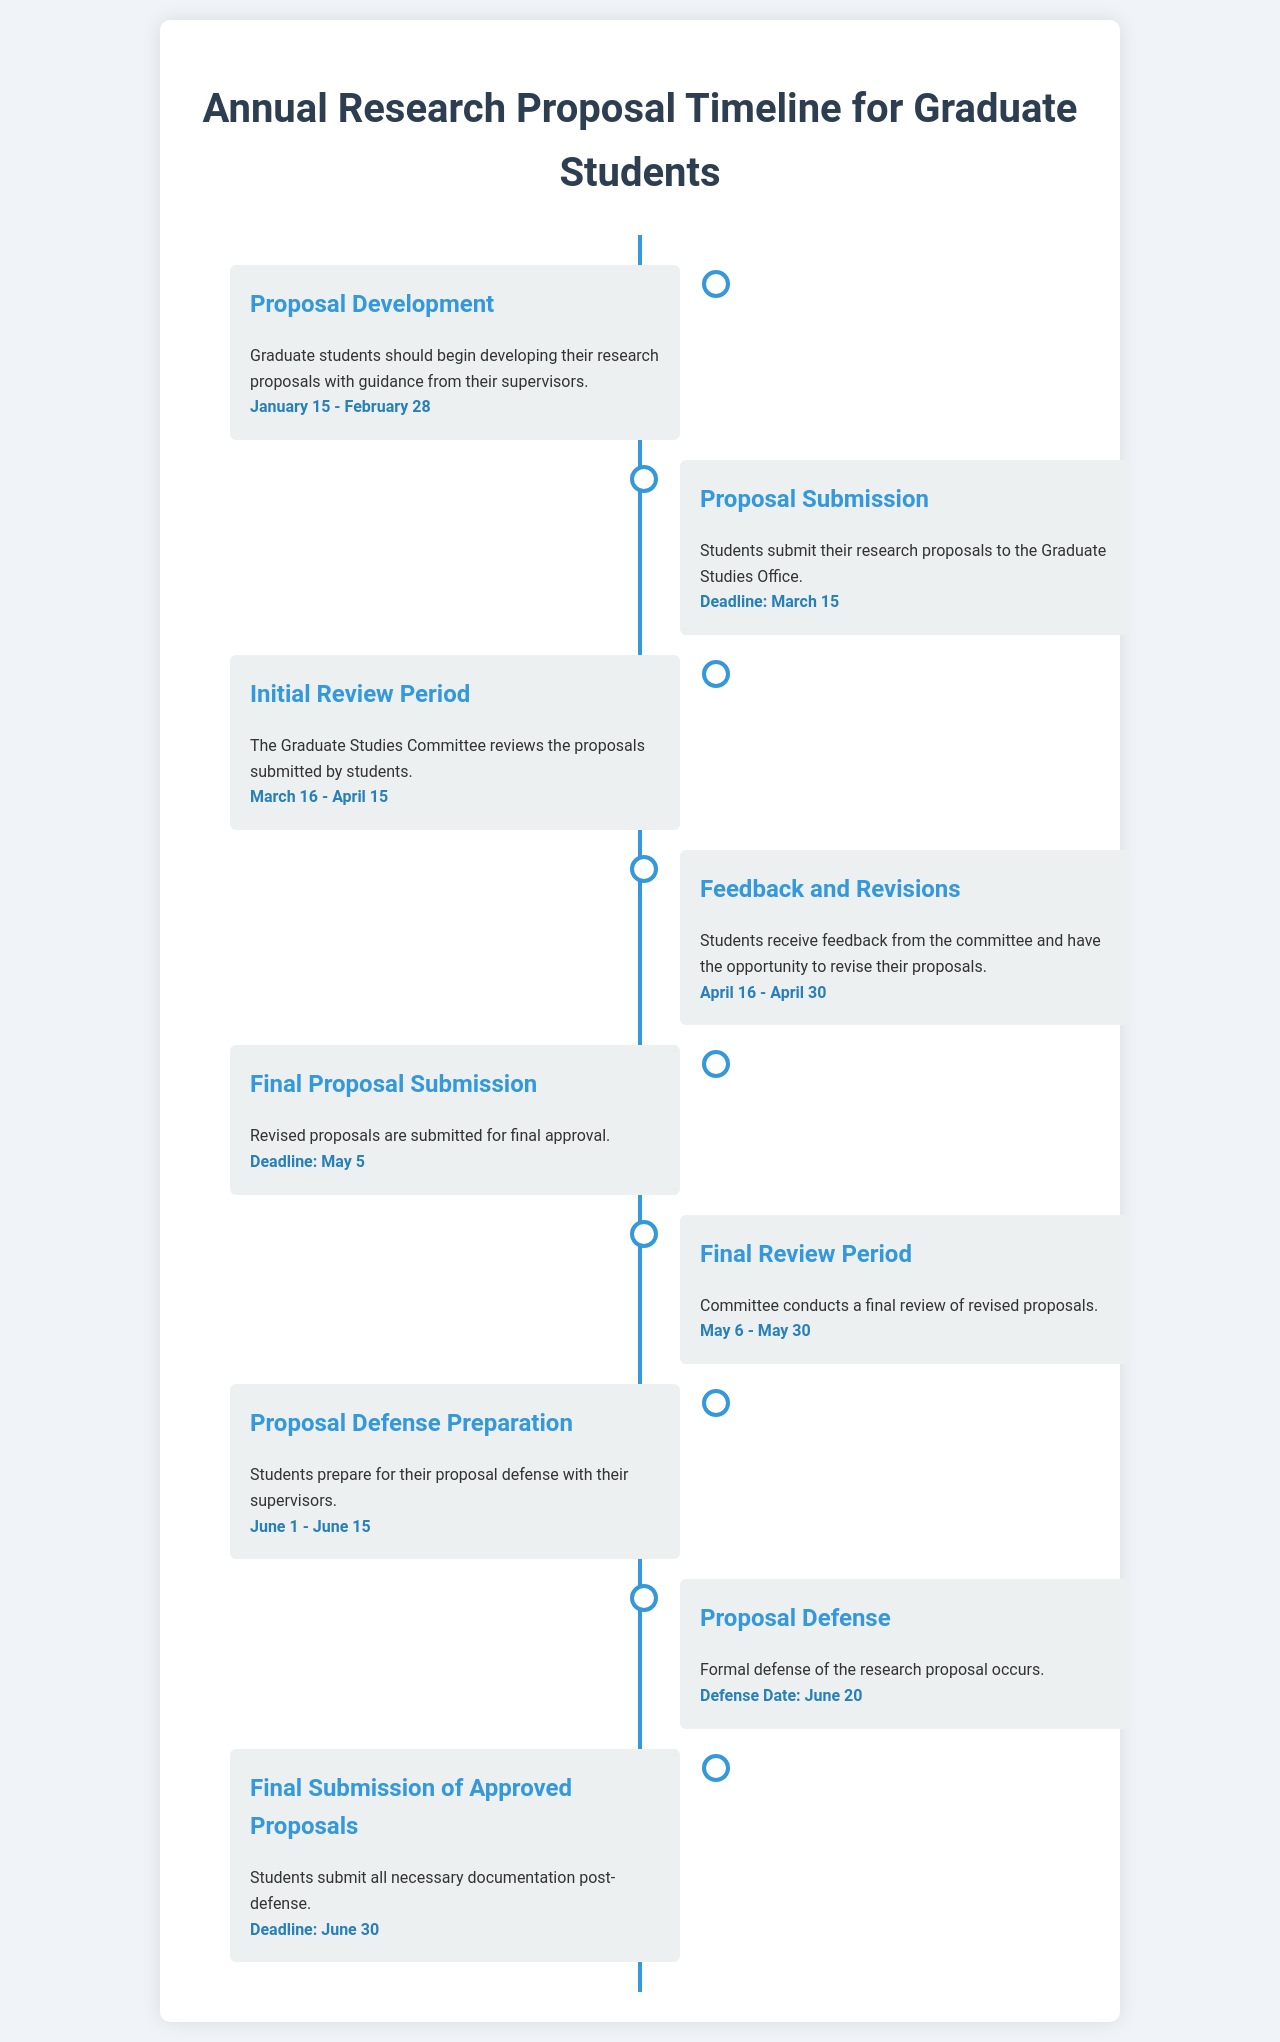what is the deadline for proposal submission? The deadline for proposal submission is mentioned explicitly in the document.
Answer: March 15 what dates are designated for the proposal defense preparation? The document specifies the period allotted for proposal defense preparation.
Answer: June 1 - June 15 when does the final review period take place? The final review period dates can be found within the timeline in the document.
Answer: May 6 - May 30 who reviews the proposals submitted by students? The document states who is responsible for the review of student proposals.
Answer: Graduate Studies Committee what is the last possible date for final submission of approved proposals? The document clearly states the final submission deadline for approved proposals.
Answer: June 30 during what period can students revise their proposals? The timeframe for revisions is detailed in the document.
Answer: April 16 - April 30 what is one of the main tasks during the proposal defense preparation? A specific task related to proposal defense preparation is mentioned in the document.
Answer: Prepare with supervisors how many days are allocated for the initial review period? The total duration of the initial review period can be calculated from the dates provided.
Answer: 30 days 